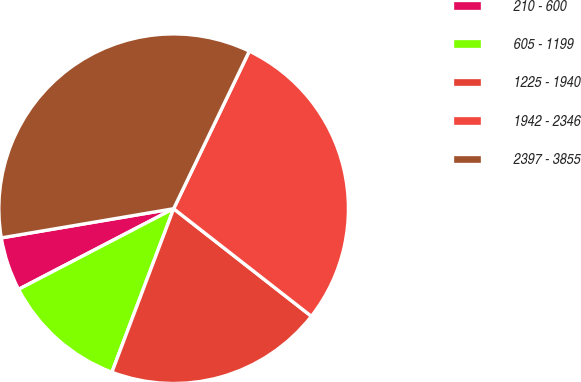Convert chart. <chart><loc_0><loc_0><loc_500><loc_500><pie_chart><fcel>210 - 600<fcel>605 - 1199<fcel>1225 - 1940<fcel>1942 - 2346<fcel>2397 - 3855<nl><fcel>4.96%<fcel>11.62%<fcel>20.19%<fcel>28.42%<fcel>34.79%<nl></chart> 